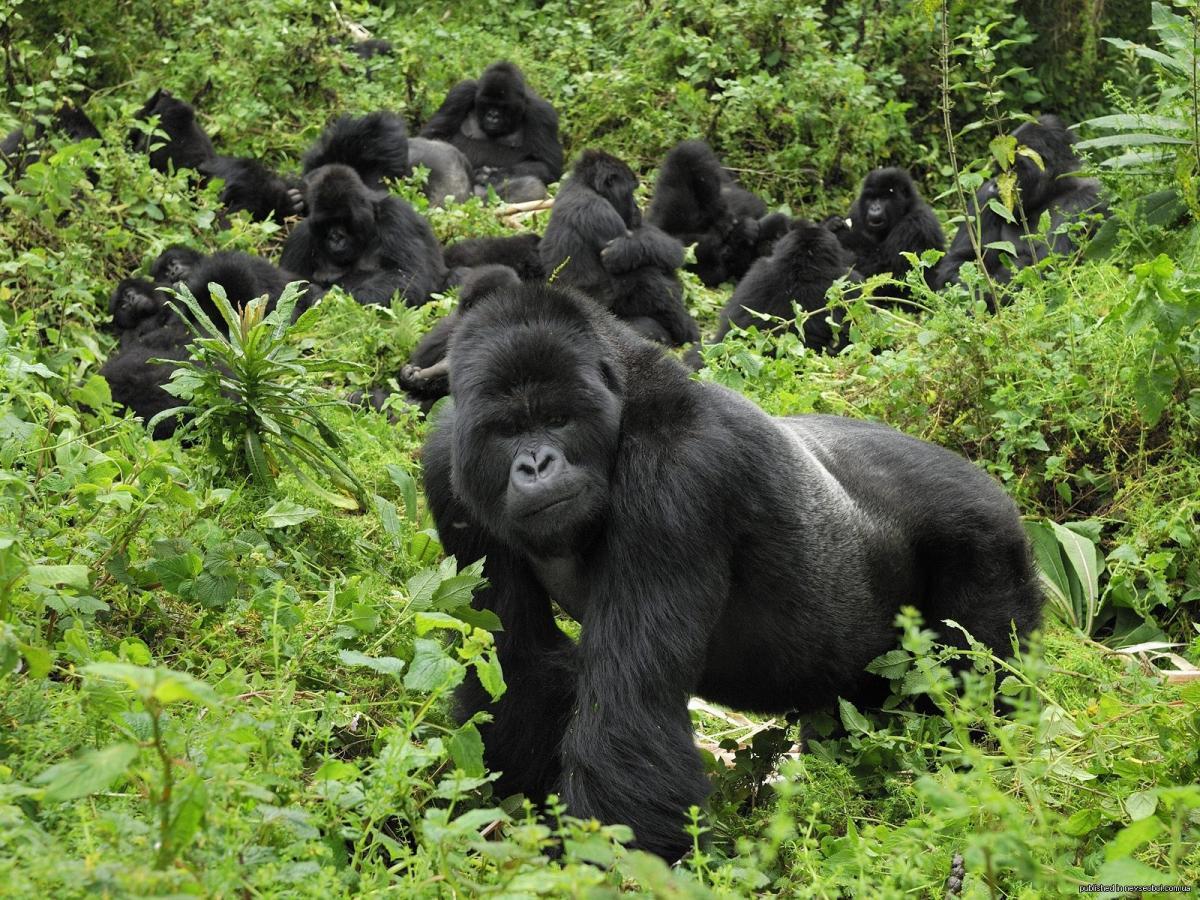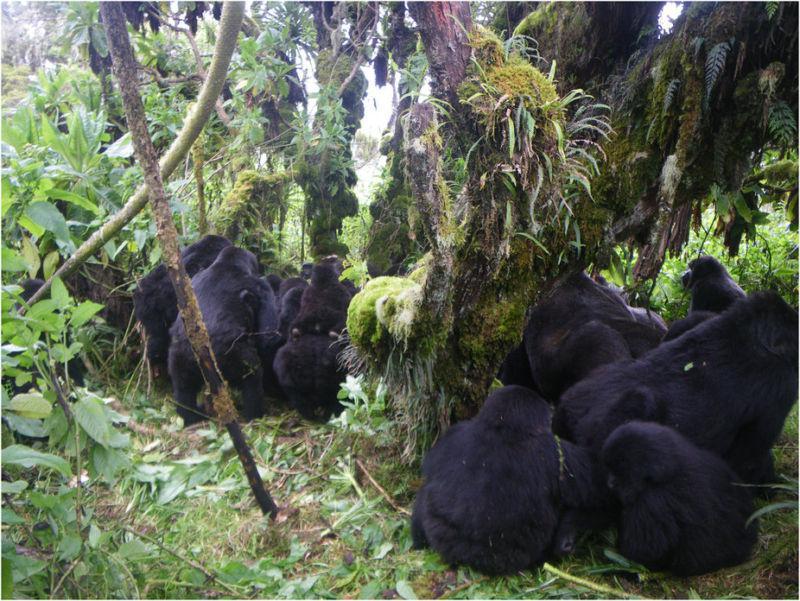The first image is the image on the left, the second image is the image on the right. Assess this claim about the two images: "There are many gorillas sitting together in the jungle.". Correct or not? Answer yes or no. Yes. The first image is the image on the left, the second image is the image on the right. For the images displayed, is the sentence "There are no more than seven gorillas." factually correct? Answer yes or no. No. 